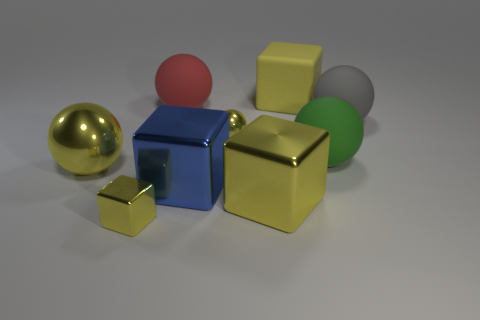Subtract all yellow cubes. How many were subtracted if there are1yellow cubes left? 2 Subtract all gray cylinders. How many yellow blocks are left? 3 Subtract all tiny cubes. How many cubes are left? 3 Subtract all gray spheres. How many spheres are left? 4 Subtract all gray blocks. Subtract all green cylinders. How many blocks are left? 4 Subtract all cubes. How many objects are left? 5 Subtract all cubes. Subtract all big gray things. How many objects are left? 4 Add 9 blue objects. How many blue objects are left? 10 Add 1 big yellow metal things. How many big yellow metal things exist? 3 Subtract 0 brown cylinders. How many objects are left? 9 